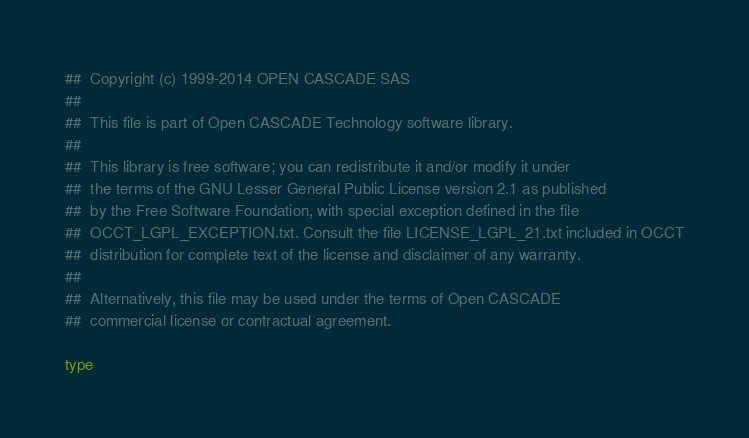Convert code to text. <code><loc_0><loc_0><loc_500><loc_500><_Nim_>##  Copyright (c) 1999-2014 OPEN CASCADE SAS
##
##  This file is part of Open CASCADE Technology software library.
##
##  This library is free software; you can redistribute it and/or modify it under
##  the terms of the GNU Lesser General Public License version 2.1 as published
##  by the Free Software Foundation, with special exception defined in the file
##  OCCT_LGPL_EXCEPTION.txt. Consult the file LICENSE_LGPL_21.txt included in OCCT
##  distribution for complete text of the license and disclaimer of any warranty.
##
##  Alternatively, this file may be used under the terms of Open CASCADE
##  commercial license or contractual agreement.

type</code> 